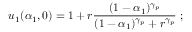Convert formula to latex. <formula><loc_0><loc_0><loc_500><loc_500>u _ { 1 } ( \alpha _ { 1 } , 0 ) = 1 + r \frac { ( 1 - \alpha _ { 1 } ) ^ { \gamma _ { p } } } { ( 1 - \alpha _ { 1 } ) ^ { \gamma _ { p } } + r ^ { \gamma _ { p } } } \, ;</formula> 